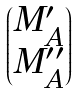Convert formula to latex. <formula><loc_0><loc_0><loc_500><loc_500>\begin{pmatrix} M ^ { \prime } _ { A } \\ M ^ { \prime \prime } _ { A } \end{pmatrix}</formula> 